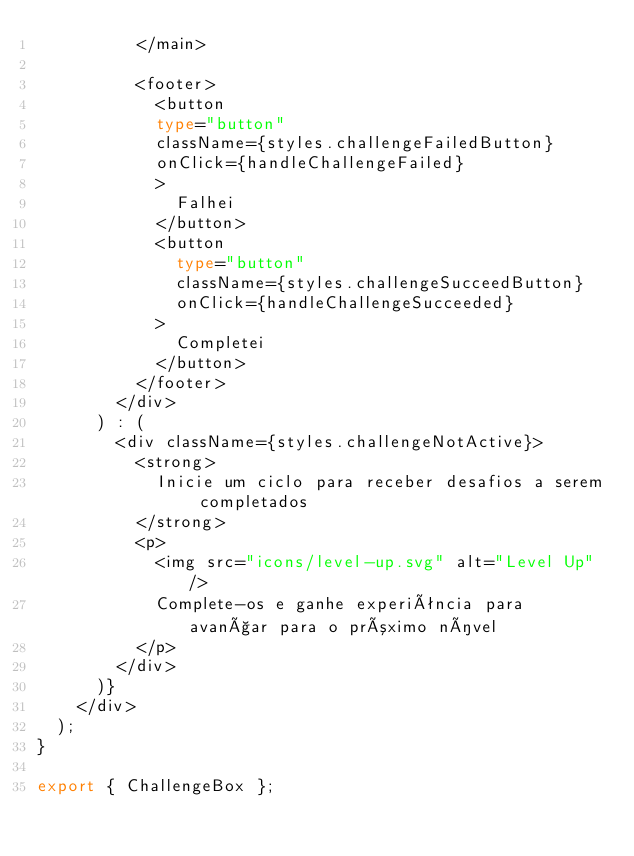<code> <loc_0><loc_0><loc_500><loc_500><_TypeScript_>          </main>

          <footer>
            <button 
            type="button" 
            className={styles.challengeFailedButton}
            onClick={handleChallengeFailed}
            >
              Falhei
            </button>
            <button 
              type="button" 
              className={styles.challengeSucceedButton}
              onClick={handleChallengeSucceeded}
            >
              Completei
            </button>
          </footer>
        </div>
      ) : (
        <div className={styles.challengeNotActive}>
          <strong>
            Inicie um ciclo para receber desafios a serem completados
          </strong>
          <p>
            <img src="icons/level-up.svg" alt="Level Up" />
            Complete-os e ganhe experiência para avançar para o próximo nível
          </p>
        </div>
      )}
    </div>
  );
}

export { ChallengeBox };
</code> 